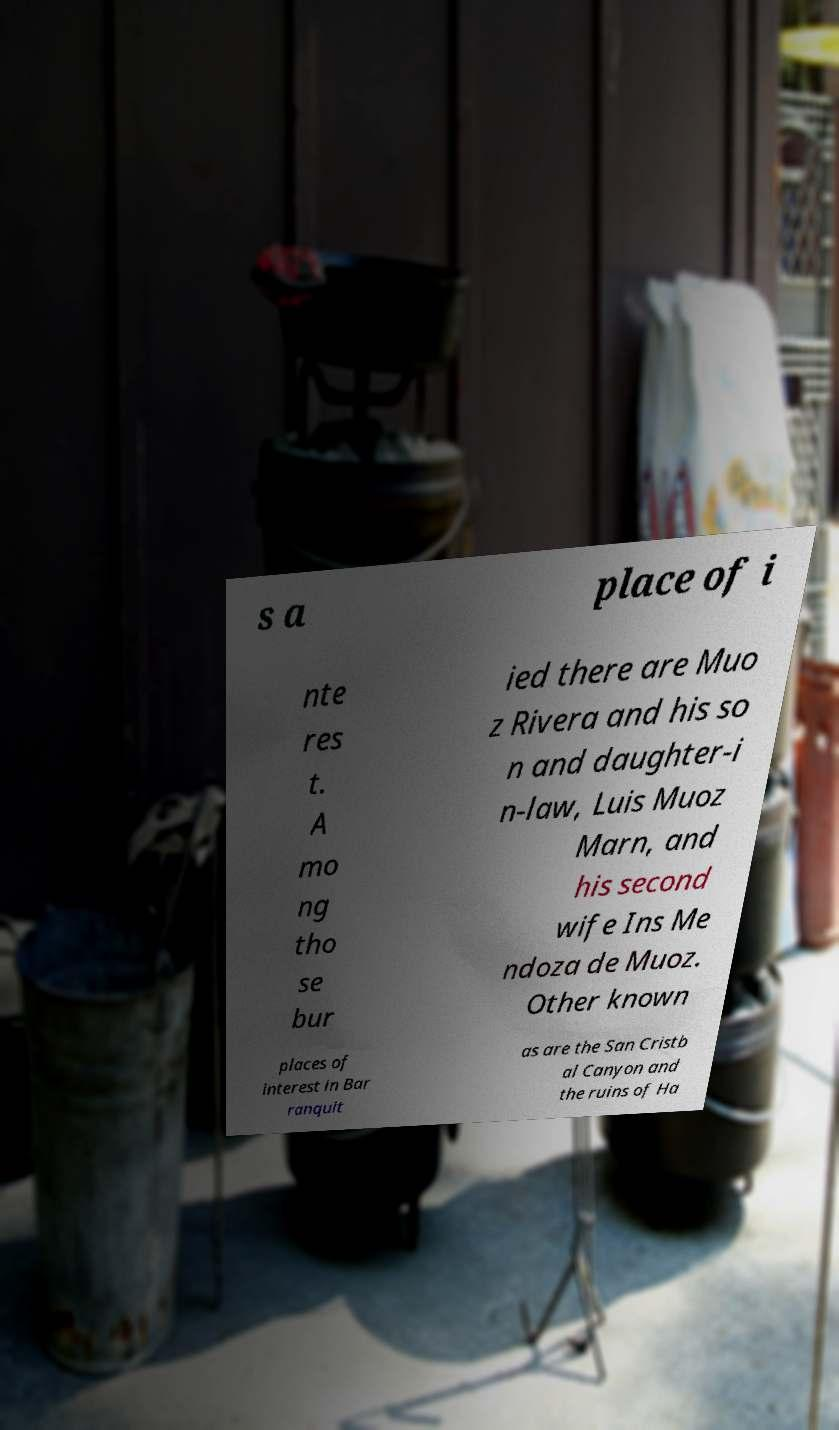Please identify and transcribe the text found in this image. s a place of i nte res t. A mo ng tho se bur ied there are Muo z Rivera and his so n and daughter-i n-law, Luis Muoz Marn, and his second wife Ins Me ndoza de Muoz. Other known places of interest in Bar ranquit as are the San Cristb al Canyon and the ruins of Ha 